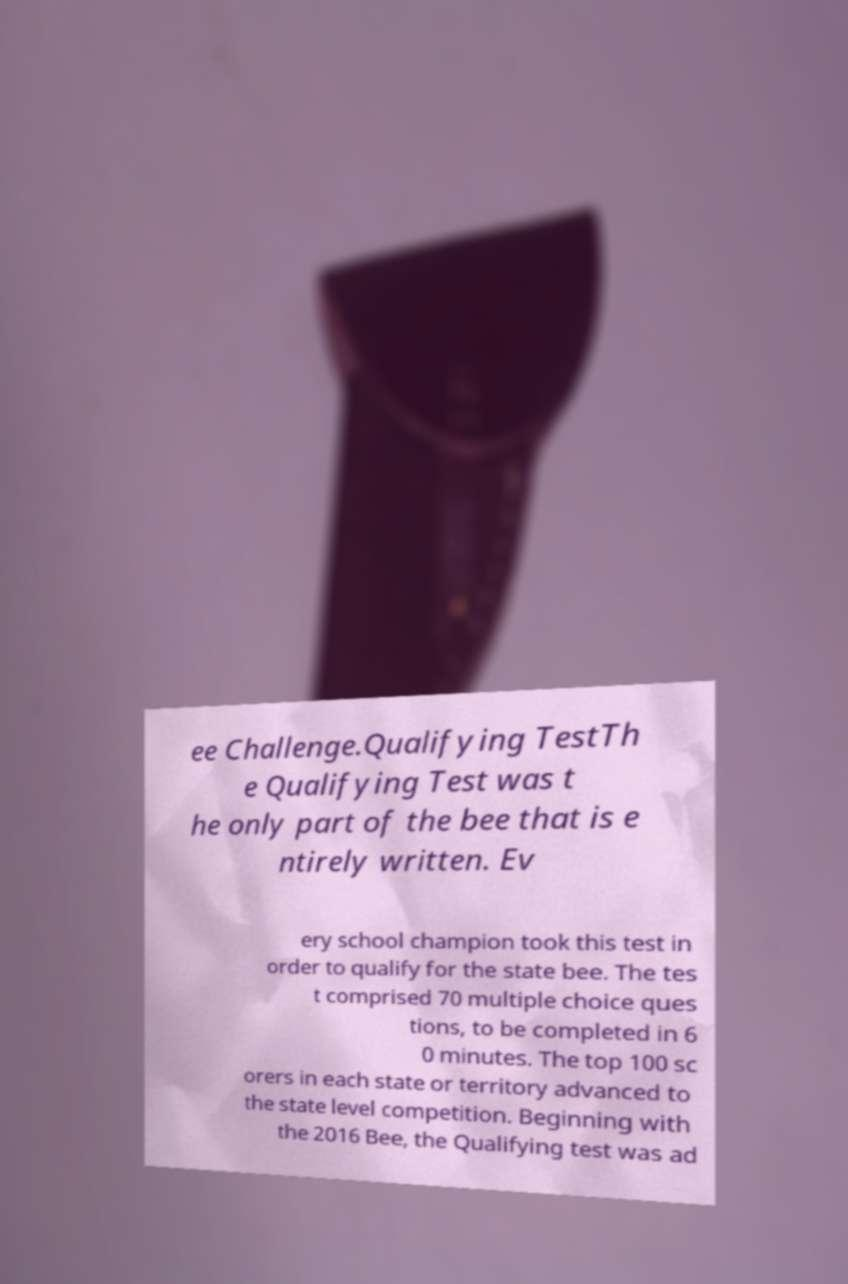I need the written content from this picture converted into text. Can you do that? ee Challenge.Qualifying TestTh e Qualifying Test was t he only part of the bee that is e ntirely written. Ev ery school champion took this test in order to qualify for the state bee. The tes t comprised 70 multiple choice ques tions, to be completed in 6 0 minutes. The top 100 sc orers in each state or territory advanced to the state level competition. Beginning with the 2016 Bee, the Qualifying test was ad 